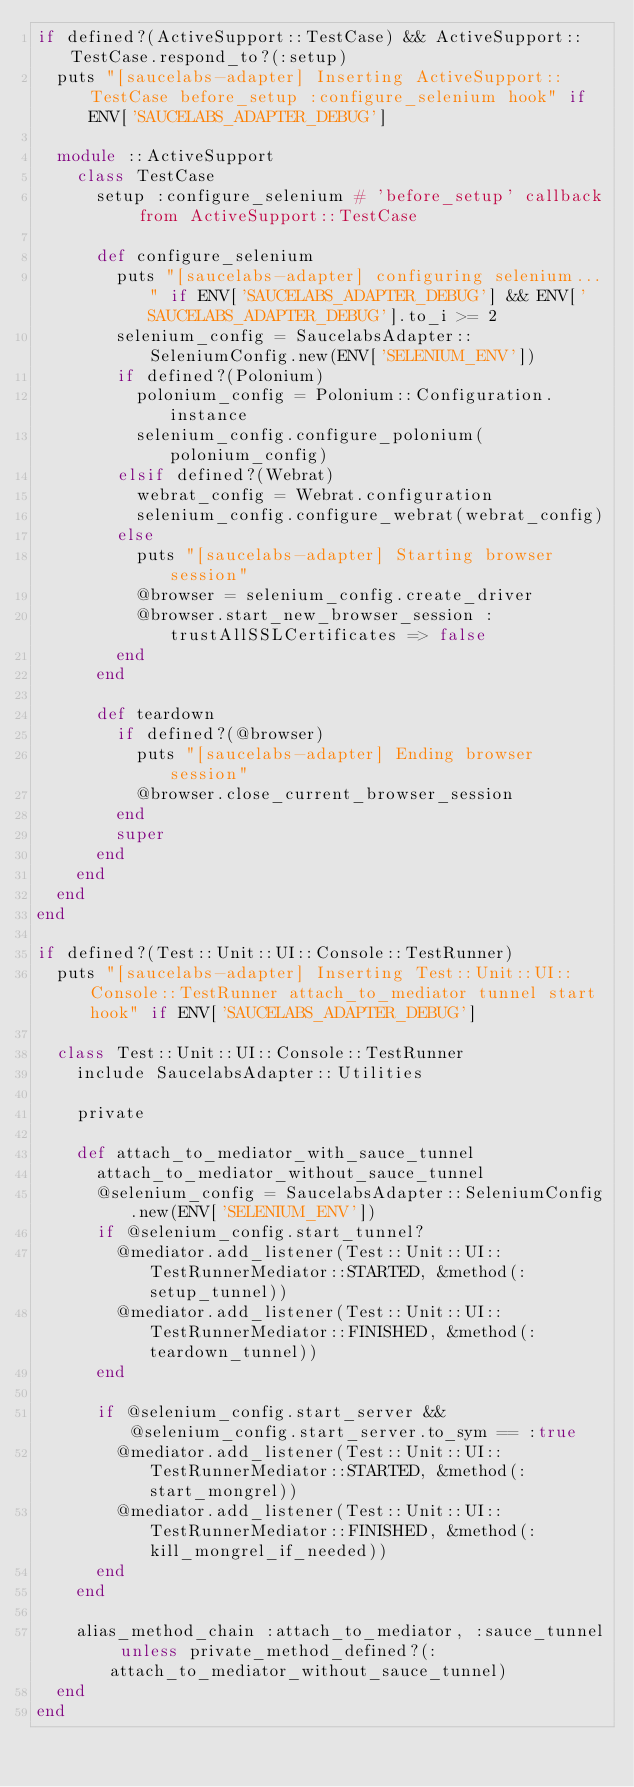<code> <loc_0><loc_0><loc_500><loc_500><_Ruby_>if defined?(ActiveSupport::TestCase) && ActiveSupport::TestCase.respond_to?(:setup)
  puts "[saucelabs-adapter] Inserting ActiveSupport::TestCase before_setup :configure_selenium hook" if ENV['SAUCELABS_ADAPTER_DEBUG']

  module ::ActiveSupport
    class TestCase
      setup :configure_selenium # 'before_setup' callback from ActiveSupport::TestCase

      def configure_selenium
        puts "[saucelabs-adapter] configuring selenium..." if ENV['SAUCELABS_ADAPTER_DEBUG'] && ENV['SAUCELABS_ADAPTER_DEBUG'].to_i >= 2
        selenium_config = SaucelabsAdapter::SeleniumConfig.new(ENV['SELENIUM_ENV'])
        if defined?(Polonium)
          polonium_config = Polonium::Configuration.instance
          selenium_config.configure_polonium(polonium_config)
        elsif defined?(Webrat)
          webrat_config = Webrat.configuration
          selenium_config.configure_webrat(webrat_config)
        else
          puts "[saucelabs-adapter] Starting browser session"
          @browser = selenium_config.create_driver
          @browser.start_new_browser_session :trustAllSSLCertificates => false
        end
      end

      def teardown
        if defined?(@browser)
          puts "[saucelabs-adapter] Ending browser session"
          @browser.close_current_browser_session
        end
        super
      end
    end
  end
end

if defined?(Test::Unit::UI::Console::TestRunner)
  puts "[saucelabs-adapter] Inserting Test::Unit::UI::Console::TestRunner attach_to_mediator tunnel start hook" if ENV['SAUCELABS_ADAPTER_DEBUG']

  class Test::Unit::UI::Console::TestRunner
    include SaucelabsAdapter::Utilities

    private

    def attach_to_mediator_with_sauce_tunnel
      attach_to_mediator_without_sauce_tunnel
      @selenium_config = SaucelabsAdapter::SeleniumConfig.new(ENV['SELENIUM_ENV'])
      if @selenium_config.start_tunnel?
        @mediator.add_listener(Test::Unit::UI::TestRunnerMediator::STARTED, &method(:setup_tunnel))
        @mediator.add_listener(Test::Unit::UI::TestRunnerMediator::FINISHED, &method(:teardown_tunnel))
      end

      if @selenium_config.start_server && @selenium_config.start_server.to_sym == :true
        @mediator.add_listener(Test::Unit::UI::TestRunnerMediator::STARTED, &method(:start_mongrel))
        @mediator.add_listener(Test::Unit::UI::TestRunnerMediator::FINISHED, &method(:kill_mongrel_if_needed))
      end
    end

    alias_method_chain :attach_to_mediator, :sauce_tunnel unless private_method_defined?(:attach_to_mediator_without_sauce_tunnel)
  end
end
</code> 